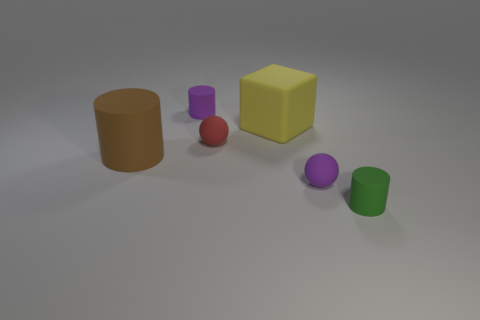Are there more things behind the purple ball than big yellow rubber cubes in front of the brown cylinder?
Make the answer very short. Yes. Is the size of the purple thing behind the brown rubber thing the same as the green cylinder?
Your response must be concise. Yes. There is a tiny matte cylinder left of the matte ball that is to the right of the big yellow block; how many tiny green cylinders are to the left of it?
Give a very brief answer. 0. What size is the object that is both on the left side of the tiny red sphere and behind the red thing?
Offer a very short reply. Small. What number of other objects are there of the same shape as the yellow rubber object?
Your response must be concise. 0. What number of purple matte things are in front of the brown matte cylinder?
Offer a very short reply. 1. Is the number of purple matte objects that are to the right of the brown rubber object less than the number of green objects that are behind the small green object?
Ensure brevity in your answer.  No. What is the shape of the tiny matte thing that is in front of the small purple rubber object right of the purple object behind the tiny purple sphere?
Your answer should be very brief. Cylinder. There is a matte object that is both to the left of the tiny green rubber cylinder and in front of the large brown thing; what is its shape?
Make the answer very short. Sphere. Is there a cyan cube made of the same material as the big yellow cube?
Ensure brevity in your answer.  No. 